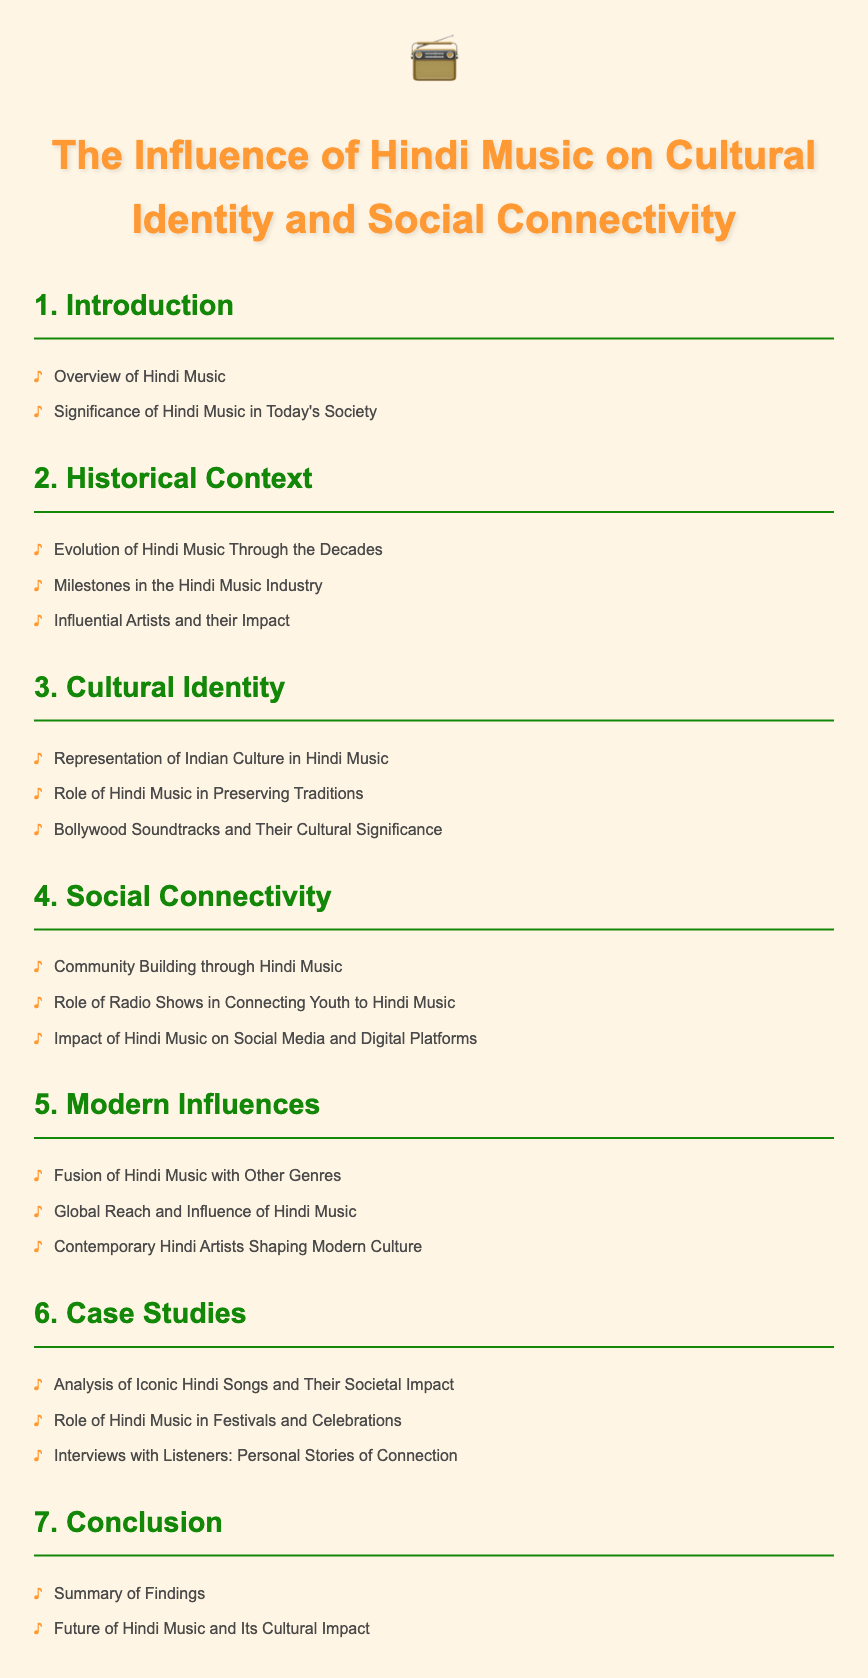What are the two main topics covered in the introduction? The introduction section lists the overview of Hindi Music and its significance in today's society, which are the two main topics covered.
Answer: Overview of Hindi Music, Significance of Hindi Music in Today's Society What does the section "Cultural Identity" focus on? The "Cultural Identity" section includes representation of Indian culture, role in preserving traditions, and Bollywood soundtracks.
Answer: Representation of Indian Culture in Hindi Music, Role of Hindi Music in Preserving Traditions, Bollywood Soundtracks and Their Cultural Significance Which section covers the evolution of Hindi music? The "Historical Context" section specifically addresses the evolution of Hindi music through the decades, highlighting its history.
Answer: Evolution of Hindi Music Through the Decades What role do radio shows play according to the document? The document states that radio shows contribute significantly to connecting youth to Hindi music as part of the "Social Connectivity" section.
Answer: Connecting Youth to Hindi Music How many case studies are mentioned? The "Case Studies" section includes three distinct items, highlighting specific analyses and interviews.
Answer: Three What is the final section of the document? The last section of the document is the "Conclusion," summarizing the findings and future impacts of Hindi music.
Answer: Conclusion What type of influences are discussed in the modern context? The "Modern Influences" section discusses the fusion of Hindi music with other genres, its global reach, and the contemporary artists shaping culture.
Answer: Fusion of Hindi Music with Other Genres Which section includes personal stories? The "Case Studies" section encompasses interviews with listeners that feature their personal stories of connection.
Answer: Interviews with Listeners: Personal Stories of Connection 